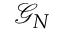<formula> <loc_0><loc_0><loc_500><loc_500>\mathcal { G } _ { N }</formula> 